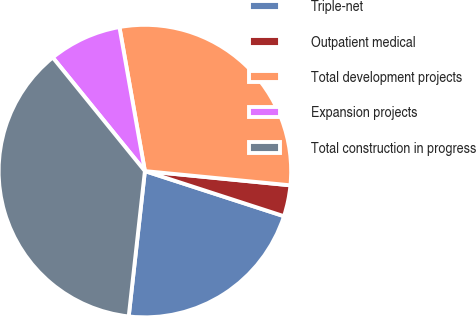Convert chart. <chart><loc_0><loc_0><loc_500><loc_500><pie_chart><fcel>Triple-net<fcel>Outpatient medical<fcel>Total development projects<fcel>Expansion projects<fcel>Total construction in progress<nl><fcel>21.77%<fcel>3.44%<fcel>29.34%<fcel>8.06%<fcel>37.39%<nl></chart> 